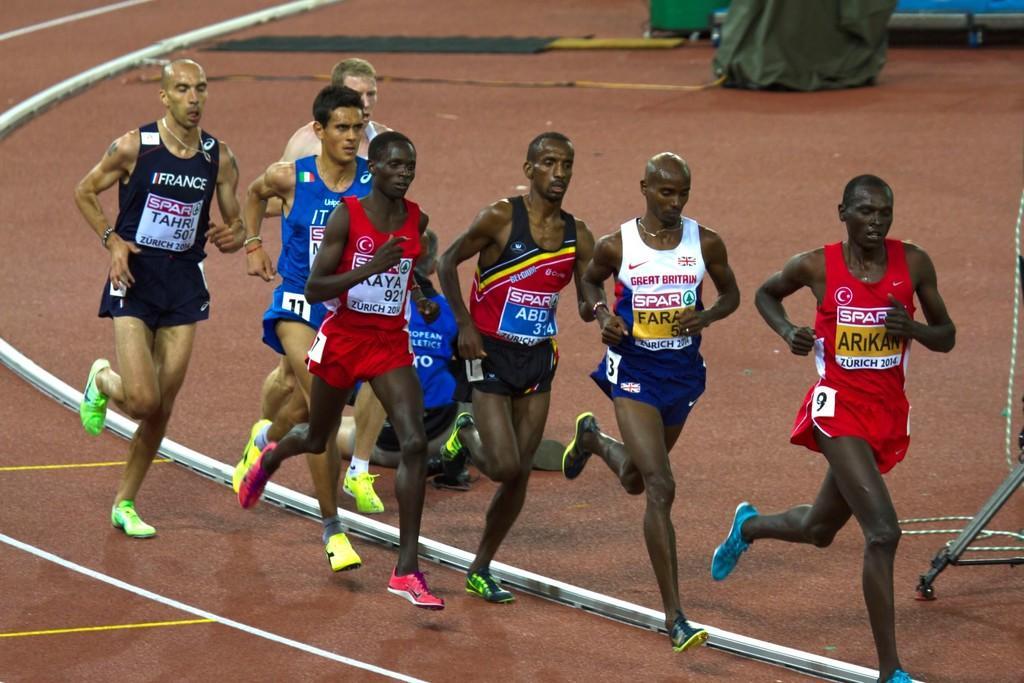Can you describe this image briefly? In this picture I can see on the right side a man is running, he wore red color dress. In the middle a group of persons are running. At the bottom there are white color lines. 